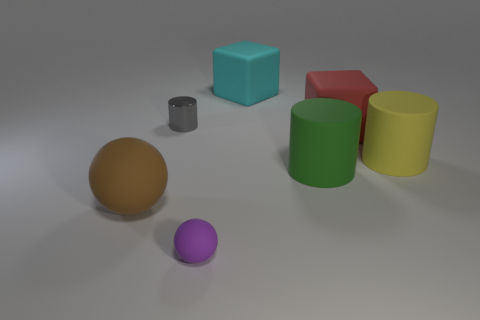What number of big brown matte balls are in front of the big block that is in front of the cyan object?
Provide a succinct answer. 1. Is there any other thing that has the same material as the cyan thing?
Your answer should be compact. Yes. The large object behind the cylinder that is on the left side of the rubber sphere in front of the large brown matte object is made of what material?
Provide a short and direct response. Rubber. There is a big thing that is both in front of the yellow matte object and behind the big brown thing; what material is it?
Your answer should be compact. Rubber. What number of other matte objects have the same shape as the big cyan object?
Provide a short and direct response. 1. There is a cylinder behind the matte cylinder to the right of the red thing; what size is it?
Offer a very short reply. Small. What number of things are in front of the big matte thing left of the matte block that is to the left of the green matte cylinder?
Your answer should be compact. 1. What number of objects are both to the right of the metallic object and behind the red block?
Your answer should be very brief. 1. Is the number of purple matte things in front of the big yellow matte cylinder greater than the number of large brown rubber cubes?
Offer a terse response. Yes. How many yellow rubber things have the same size as the green matte cylinder?
Your answer should be compact. 1. 